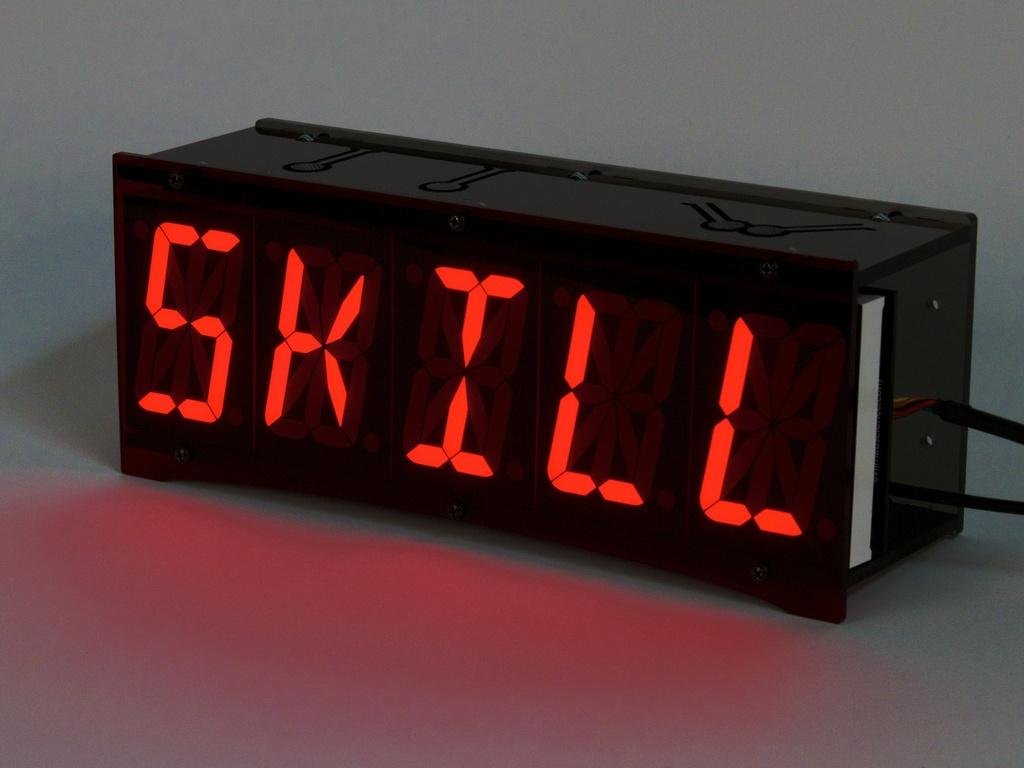<image>
Relay a brief, clear account of the picture shown. A black electronic device has SKILL in red lettering on the front. 